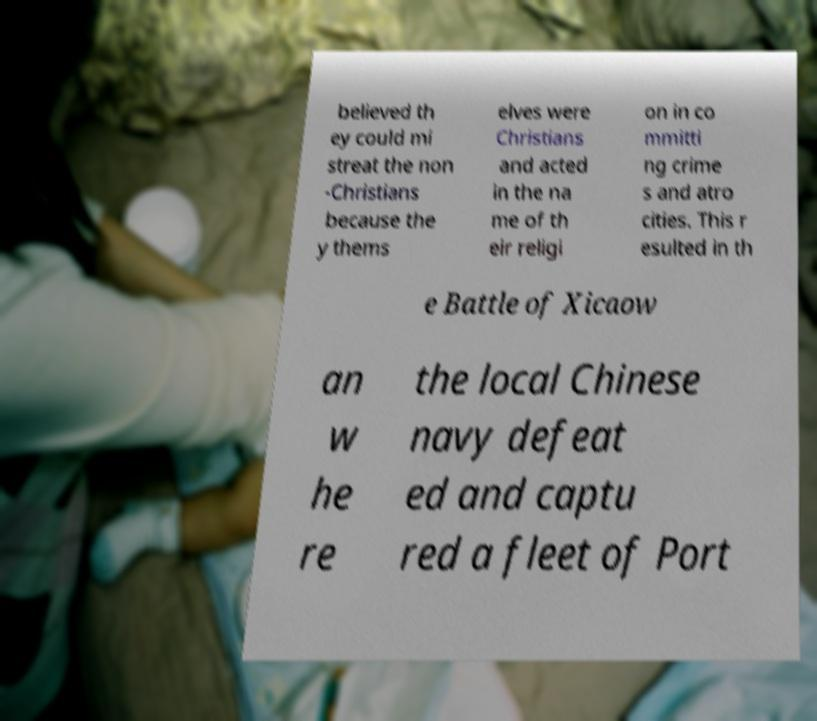I need the written content from this picture converted into text. Can you do that? believed th ey could mi streat the non -Christians because the y thems elves were Christians and acted in the na me of th eir religi on in co mmitti ng crime s and atro cities. This r esulted in th e Battle of Xicaow an w he re the local Chinese navy defeat ed and captu red a fleet of Port 